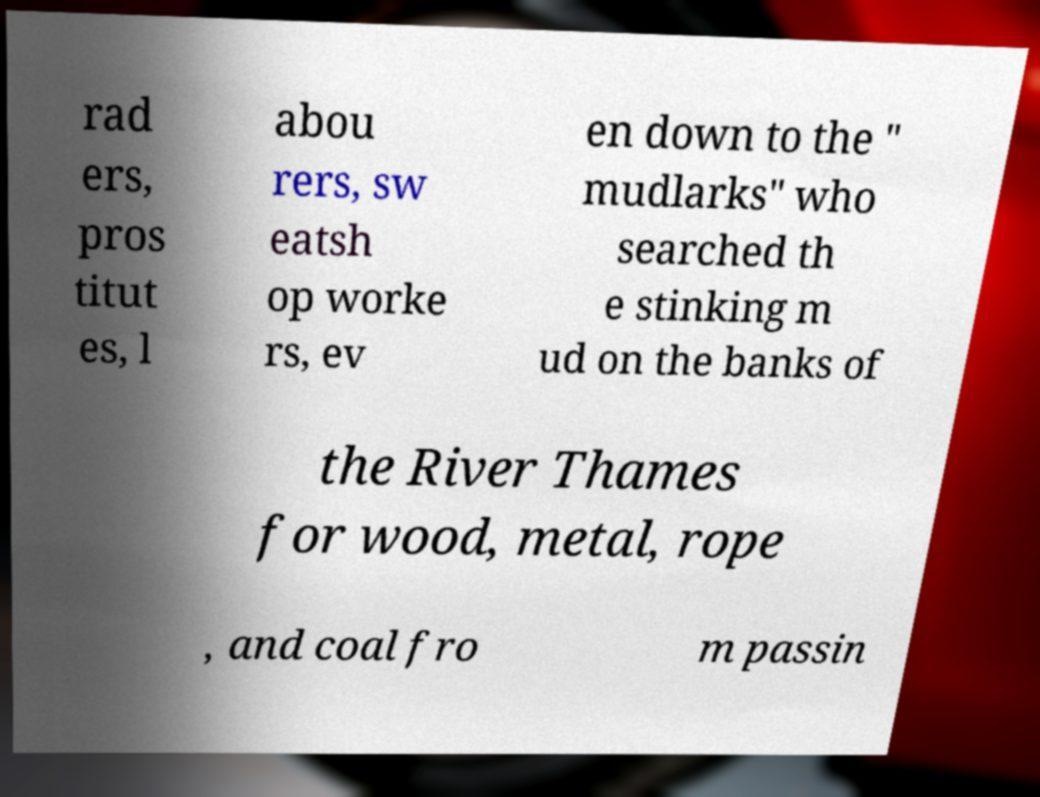Can you accurately transcribe the text from the provided image for me? rad ers, pros titut es, l abou rers, sw eatsh op worke rs, ev en down to the " mudlarks" who searched th e stinking m ud on the banks of the River Thames for wood, metal, rope , and coal fro m passin 